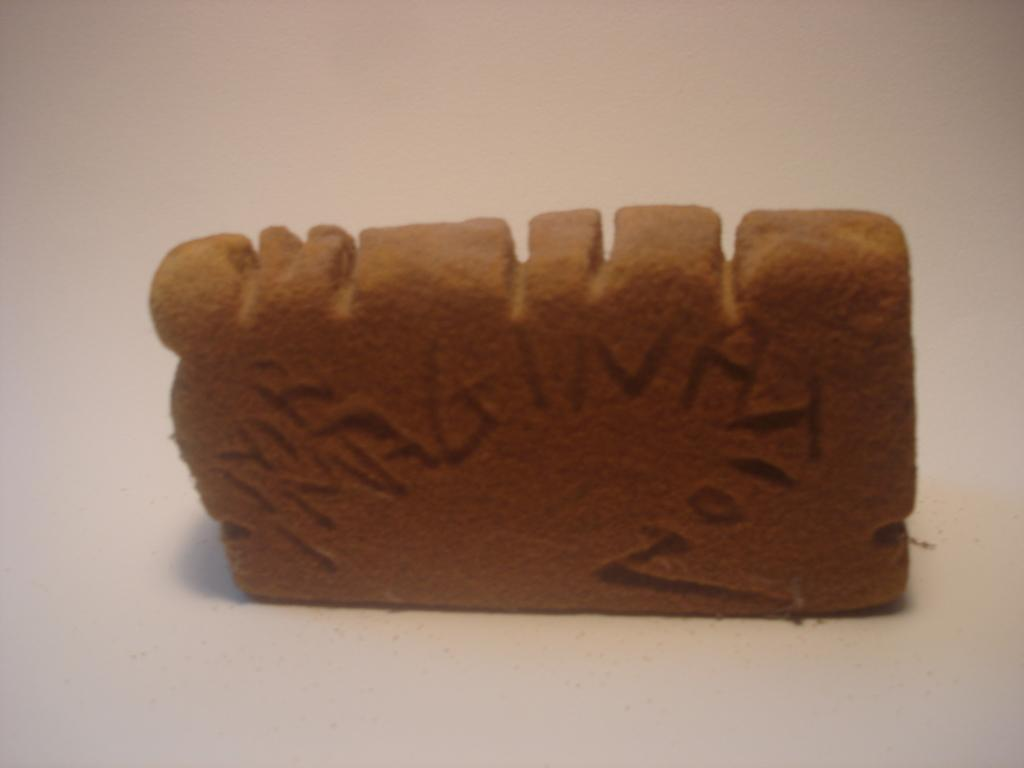What is the main object in the image? The main object in the image is either edible or a toy and is brown in color. What color is the background of the image? The background of the image is white. What might the white background be? The white background is likely a table. What type of insurance policy is being discussed in the image? There is no mention of insurance in the image; it features an object that is either edible or a toy and a white background. Can you see a frog in the image? There is no frog present in the image. 